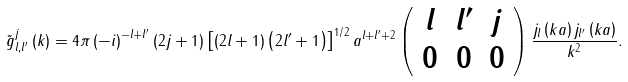Convert formula to latex. <formula><loc_0><loc_0><loc_500><loc_500>\tilde { g } _ { l , l ^ { \prime } } ^ { j } \left ( k \right ) = 4 \pi \left ( - i \right ) ^ { - l + l ^ { \prime } } \left ( 2 j + 1 \right ) \left [ \left ( 2 l + 1 \right ) \left ( 2 l ^ { \prime } + 1 \right ) \right ] ^ { 1 / 2 } a ^ { l + l ^ { \prime } + 2 } \left ( \begin{array} [ c ] { c c c } l & l ^ { \prime } & j \\ 0 & 0 & 0 \end{array} \right ) \frac { j _ { l } \left ( k a \right ) j _ { l ^ { \prime } } \left ( k a \right ) } { k ^ { 2 } } .</formula> 